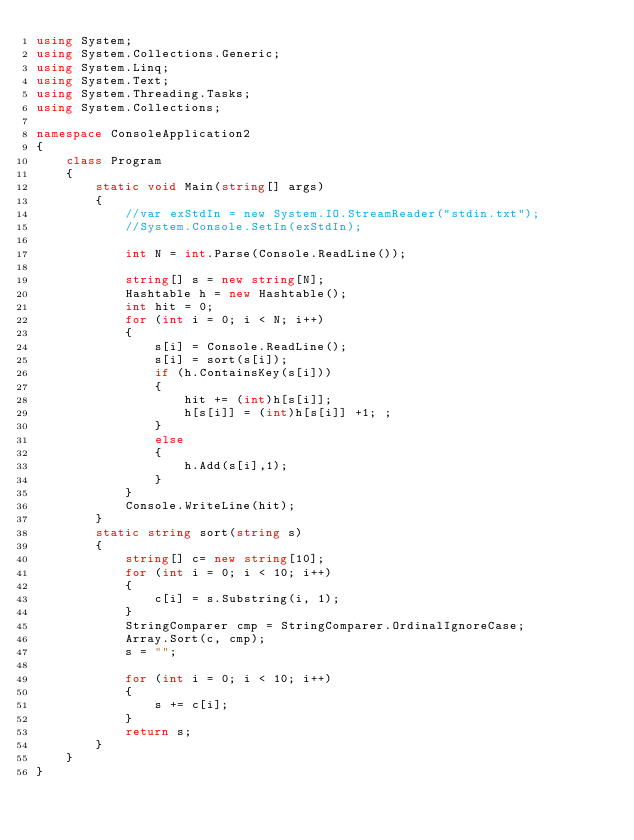<code> <loc_0><loc_0><loc_500><loc_500><_C#_>using System;
using System.Collections.Generic;
using System.Linq;
using System.Text;
using System.Threading.Tasks;
using System.Collections;

namespace ConsoleApplication2
{
    class Program
    {
        static void Main(string[] args)
        {
            //var exStdIn = new System.IO.StreamReader("stdin.txt");
            //System.Console.SetIn(exStdIn);

            int N = int.Parse(Console.ReadLine());

            string[] s = new string[N];
            Hashtable h = new Hashtable();
            int hit = 0;
            for (int i = 0; i < N; i++)
            {
                s[i] = Console.ReadLine();
                s[i] = sort(s[i]);
                if (h.ContainsKey(s[i]))
                {
                    hit += (int)h[s[i]];
                    h[s[i]] = (int)h[s[i]] +1; ;
                }
                else
                {
                    h.Add(s[i],1);
                }
            }
            Console.WriteLine(hit);
        }
        static string sort(string s)
        {
            string[] c= new string[10];
            for (int i = 0; i < 10; i++)
            {
                c[i] = s.Substring(i, 1);
            }
            StringComparer cmp = StringComparer.OrdinalIgnoreCase;
            Array.Sort(c, cmp);
            s = "";

            for (int i = 0; i < 10; i++)
            {
                s += c[i];
            }
            return s;
        }
    }
}
</code> 